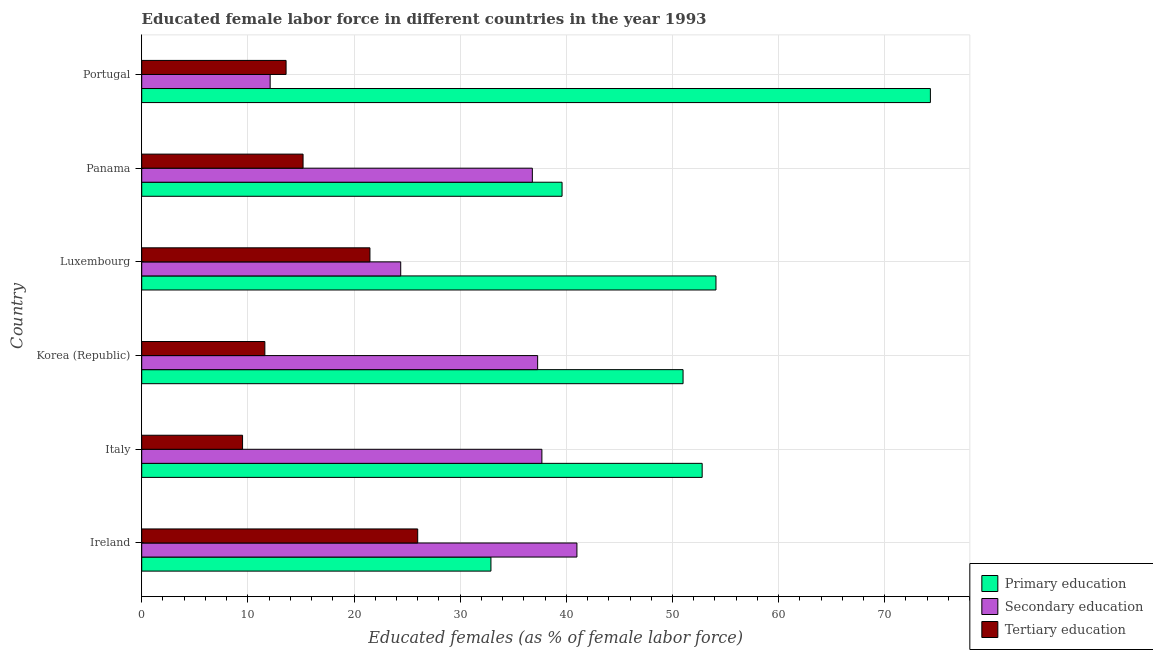How many groups of bars are there?
Your response must be concise. 6. What is the label of the 5th group of bars from the top?
Provide a succinct answer. Italy. What is the percentage of female labor force who received tertiary education in Luxembourg?
Make the answer very short. 21.5. Across all countries, what is the minimum percentage of female labor force who received tertiary education?
Offer a very short reply. 9.5. In which country was the percentage of female labor force who received tertiary education maximum?
Offer a terse response. Ireland. In which country was the percentage of female labor force who received secondary education minimum?
Provide a succinct answer. Portugal. What is the total percentage of female labor force who received tertiary education in the graph?
Provide a short and direct response. 97.4. What is the difference between the percentage of female labor force who received secondary education in Panama and that in Portugal?
Your answer should be very brief. 24.7. What is the difference between the percentage of female labor force who received primary education in Panama and the percentage of female labor force who received tertiary education in Korea (Republic)?
Provide a succinct answer. 28. What is the average percentage of female labor force who received tertiary education per country?
Give a very brief answer. 16.23. What is the difference between the percentage of female labor force who received secondary education and percentage of female labor force who received tertiary education in Italy?
Ensure brevity in your answer.  28.2. What is the ratio of the percentage of female labor force who received primary education in Korea (Republic) to that in Luxembourg?
Give a very brief answer. 0.94. Is the percentage of female labor force who received tertiary education in Korea (Republic) less than that in Panama?
Your answer should be compact. Yes. Is the difference between the percentage of female labor force who received tertiary education in Ireland and Panama greater than the difference between the percentage of female labor force who received primary education in Ireland and Panama?
Provide a short and direct response. Yes. What is the difference between the highest and the second highest percentage of female labor force who received secondary education?
Make the answer very short. 3.3. In how many countries, is the percentage of female labor force who received tertiary education greater than the average percentage of female labor force who received tertiary education taken over all countries?
Ensure brevity in your answer.  2. What does the 1st bar from the top in Italy represents?
Give a very brief answer. Tertiary education. Are all the bars in the graph horizontal?
Your answer should be very brief. Yes. How many countries are there in the graph?
Give a very brief answer. 6. Does the graph contain any zero values?
Provide a short and direct response. No. Where does the legend appear in the graph?
Your answer should be compact. Bottom right. How many legend labels are there?
Ensure brevity in your answer.  3. What is the title of the graph?
Your response must be concise. Educated female labor force in different countries in the year 1993. What is the label or title of the X-axis?
Keep it short and to the point. Educated females (as % of female labor force). What is the Educated females (as % of female labor force) in Primary education in Ireland?
Give a very brief answer. 32.9. What is the Educated females (as % of female labor force) in Secondary education in Ireland?
Offer a terse response. 41. What is the Educated females (as % of female labor force) in Tertiary education in Ireland?
Offer a very short reply. 26. What is the Educated females (as % of female labor force) of Primary education in Italy?
Give a very brief answer. 52.8. What is the Educated females (as % of female labor force) in Secondary education in Italy?
Keep it short and to the point. 37.7. What is the Educated females (as % of female labor force) of Primary education in Korea (Republic)?
Offer a very short reply. 51. What is the Educated females (as % of female labor force) in Secondary education in Korea (Republic)?
Provide a short and direct response. 37.3. What is the Educated females (as % of female labor force) of Tertiary education in Korea (Republic)?
Offer a terse response. 11.6. What is the Educated females (as % of female labor force) in Primary education in Luxembourg?
Offer a very short reply. 54.1. What is the Educated females (as % of female labor force) in Secondary education in Luxembourg?
Make the answer very short. 24.4. What is the Educated females (as % of female labor force) in Primary education in Panama?
Provide a short and direct response. 39.6. What is the Educated females (as % of female labor force) of Secondary education in Panama?
Keep it short and to the point. 36.8. What is the Educated females (as % of female labor force) in Tertiary education in Panama?
Offer a very short reply. 15.2. What is the Educated females (as % of female labor force) of Primary education in Portugal?
Your response must be concise. 74.3. What is the Educated females (as % of female labor force) of Secondary education in Portugal?
Make the answer very short. 12.1. What is the Educated females (as % of female labor force) of Tertiary education in Portugal?
Your response must be concise. 13.6. Across all countries, what is the maximum Educated females (as % of female labor force) of Primary education?
Ensure brevity in your answer.  74.3. Across all countries, what is the maximum Educated females (as % of female labor force) in Tertiary education?
Ensure brevity in your answer.  26. Across all countries, what is the minimum Educated females (as % of female labor force) of Primary education?
Provide a short and direct response. 32.9. Across all countries, what is the minimum Educated females (as % of female labor force) of Secondary education?
Give a very brief answer. 12.1. What is the total Educated females (as % of female labor force) of Primary education in the graph?
Provide a succinct answer. 304.7. What is the total Educated females (as % of female labor force) of Secondary education in the graph?
Give a very brief answer. 189.3. What is the total Educated females (as % of female labor force) in Tertiary education in the graph?
Provide a short and direct response. 97.4. What is the difference between the Educated females (as % of female labor force) of Primary education in Ireland and that in Italy?
Your response must be concise. -19.9. What is the difference between the Educated females (as % of female labor force) of Tertiary education in Ireland and that in Italy?
Your answer should be very brief. 16.5. What is the difference between the Educated females (as % of female labor force) in Primary education in Ireland and that in Korea (Republic)?
Keep it short and to the point. -18.1. What is the difference between the Educated females (as % of female labor force) of Primary education in Ireland and that in Luxembourg?
Provide a succinct answer. -21.2. What is the difference between the Educated females (as % of female labor force) of Tertiary education in Ireland and that in Luxembourg?
Your response must be concise. 4.5. What is the difference between the Educated females (as % of female labor force) in Primary education in Ireland and that in Portugal?
Make the answer very short. -41.4. What is the difference between the Educated females (as % of female labor force) in Secondary education in Ireland and that in Portugal?
Give a very brief answer. 28.9. What is the difference between the Educated females (as % of female labor force) in Primary education in Italy and that in Korea (Republic)?
Your answer should be compact. 1.8. What is the difference between the Educated females (as % of female labor force) of Primary education in Italy and that in Luxembourg?
Your response must be concise. -1.3. What is the difference between the Educated females (as % of female labor force) in Secondary education in Italy and that in Luxembourg?
Your answer should be very brief. 13.3. What is the difference between the Educated females (as % of female labor force) of Tertiary education in Italy and that in Luxembourg?
Offer a terse response. -12. What is the difference between the Educated females (as % of female labor force) in Primary education in Italy and that in Panama?
Provide a succinct answer. 13.2. What is the difference between the Educated females (as % of female labor force) in Secondary education in Italy and that in Panama?
Provide a succinct answer. 0.9. What is the difference between the Educated females (as % of female labor force) in Primary education in Italy and that in Portugal?
Provide a succinct answer. -21.5. What is the difference between the Educated females (as % of female labor force) of Secondary education in Italy and that in Portugal?
Your response must be concise. 25.6. What is the difference between the Educated females (as % of female labor force) of Tertiary education in Italy and that in Portugal?
Your answer should be compact. -4.1. What is the difference between the Educated females (as % of female labor force) of Secondary education in Korea (Republic) and that in Luxembourg?
Your answer should be very brief. 12.9. What is the difference between the Educated females (as % of female labor force) in Primary education in Korea (Republic) and that in Portugal?
Give a very brief answer. -23.3. What is the difference between the Educated females (as % of female labor force) of Secondary education in Korea (Republic) and that in Portugal?
Your answer should be compact. 25.2. What is the difference between the Educated females (as % of female labor force) of Tertiary education in Luxembourg and that in Panama?
Make the answer very short. 6.3. What is the difference between the Educated females (as % of female labor force) in Primary education in Luxembourg and that in Portugal?
Ensure brevity in your answer.  -20.2. What is the difference between the Educated females (as % of female labor force) of Secondary education in Luxembourg and that in Portugal?
Keep it short and to the point. 12.3. What is the difference between the Educated females (as % of female labor force) of Tertiary education in Luxembourg and that in Portugal?
Make the answer very short. 7.9. What is the difference between the Educated females (as % of female labor force) of Primary education in Panama and that in Portugal?
Your answer should be compact. -34.7. What is the difference between the Educated females (as % of female labor force) of Secondary education in Panama and that in Portugal?
Give a very brief answer. 24.7. What is the difference between the Educated females (as % of female labor force) in Primary education in Ireland and the Educated females (as % of female labor force) in Secondary education in Italy?
Make the answer very short. -4.8. What is the difference between the Educated females (as % of female labor force) in Primary education in Ireland and the Educated females (as % of female labor force) in Tertiary education in Italy?
Give a very brief answer. 23.4. What is the difference between the Educated females (as % of female labor force) in Secondary education in Ireland and the Educated females (as % of female labor force) in Tertiary education in Italy?
Your response must be concise. 31.5. What is the difference between the Educated females (as % of female labor force) in Primary education in Ireland and the Educated females (as % of female labor force) in Tertiary education in Korea (Republic)?
Provide a succinct answer. 21.3. What is the difference between the Educated females (as % of female labor force) in Secondary education in Ireland and the Educated females (as % of female labor force) in Tertiary education in Korea (Republic)?
Provide a short and direct response. 29.4. What is the difference between the Educated females (as % of female labor force) of Primary education in Ireland and the Educated females (as % of female labor force) of Tertiary education in Luxembourg?
Make the answer very short. 11.4. What is the difference between the Educated females (as % of female labor force) of Primary education in Ireland and the Educated females (as % of female labor force) of Tertiary education in Panama?
Provide a short and direct response. 17.7. What is the difference between the Educated females (as % of female labor force) of Secondary education in Ireland and the Educated females (as % of female labor force) of Tertiary education in Panama?
Your answer should be compact. 25.8. What is the difference between the Educated females (as % of female labor force) in Primary education in Ireland and the Educated females (as % of female labor force) in Secondary education in Portugal?
Make the answer very short. 20.8. What is the difference between the Educated females (as % of female labor force) in Primary education in Ireland and the Educated females (as % of female labor force) in Tertiary education in Portugal?
Offer a terse response. 19.3. What is the difference between the Educated females (as % of female labor force) in Secondary education in Ireland and the Educated females (as % of female labor force) in Tertiary education in Portugal?
Ensure brevity in your answer.  27.4. What is the difference between the Educated females (as % of female labor force) of Primary education in Italy and the Educated females (as % of female labor force) of Tertiary education in Korea (Republic)?
Provide a succinct answer. 41.2. What is the difference between the Educated females (as % of female labor force) in Secondary education in Italy and the Educated females (as % of female labor force) in Tertiary education in Korea (Republic)?
Keep it short and to the point. 26.1. What is the difference between the Educated females (as % of female labor force) in Primary education in Italy and the Educated females (as % of female labor force) in Secondary education in Luxembourg?
Your response must be concise. 28.4. What is the difference between the Educated females (as % of female labor force) in Primary education in Italy and the Educated females (as % of female labor force) in Tertiary education in Luxembourg?
Your response must be concise. 31.3. What is the difference between the Educated females (as % of female labor force) of Secondary education in Italy and the Educated females (as % of female labor force) of Tertiary education in Luxembourg?
Your answer should be very brief. 16.2. What is the difference between the Educated females (as % of female labor force) of Primary education in Italy and the Educated females (as % of female labor force) of Secondary education in Panama?
Your answer should be compact. 16. What is the difference between the Educated females (as % of female labor force) of Primary education in Italy and the Educated females (as % of female labor force) of Tertiary education in Panama?
Make the answer very short. 37.6. What is the difference between the Educated females (as % of female labor force) in Secondary education in Italy and the Educated females (as % of female labor force) in Tertiary education in Panama?
Give a very brief answer. 22.5. What is the difference between the Educated females (as % of female labor force) of Primary education in Italy and the Educated females (as % of female labor force) of Secondary education in Portugal?
Make the answer very short. 40.7. What is the difference between the Educated females (as % of female labor force) in Primary education in Italy and the Educated females (as % of female labor force) in Tertiary education in Portugal?
Your answer should be compact. 39.2. What is the difference between the Educated females (as % of female labor force) of Secondary education in Italy and the Educated females (as % of female labor force) of Tertiary education in Portugal?
Your response must be concise. 24.1. What is the difference between the Educated females (as % of female labor force) of Primary education in Korea (Republic) and the Educated females (as % of female labor force) of Secondary education in Luxembourg?
Offer a terse response. 26.6. What is the difference between the Educated females (as % of female labor force) in Primary education in Korea (Republic) and the Educated females (as % of female labor force) in Tertiary education in Luxembourg?
Make the answer very short. 29.5. What is the difference between the Educated females (as % of female labor force) in Primary education in Korea (Republic) and the Educated females (as % of female labor force) in Secondary education in Panama?
Provide a short and direct response. 14.2. What is the difference between the Educated females (as % of female labor force) in Primary education in Korea (Republic) and the Educated females (as % of female labor force) in Tertiary education in Panama?
Your answer should be very brief. 35.8. What is the difference between the Educated females (as % of female labor force) of Secondary education in Korea (Republic) and the Educated females (as % of female labor force) of Tertiary education in Panama?
Your answer should be very brief. 22.1. What is the difference between the Educated females (as % of female labor force) of Primary education in Korea (Republic) and the Educated females (as % of female labor force) of Secondary education in Portugal?
Give a very brief answer. 38.9. What is the difference between the Educated females (as % of female labor force) of Primary education in Korea (Republic) and the Educated females (as % of female labor force) of Tertiary education in Portugal?
Your response must be concise. 37.4. What is the difference between the Educated females (as % of female labor force) of Secondary education in Korea (Republic) and the Educated females (as % of female labor force) of Tertiary education in Portugal?
Make the answer very short. 23.7. What is the difference between the Educated females (as % of female labor force) in Primary education in Luxembourg and the Educated females (as % of female labor force) in Secondary education in Panama?
Give a very brief answer. 17.3. What is the difference between the Educated females (as % of female labor force) in Primary education in Luxembourg and the Educated females (as % of female labor force) in Tertiary education in Panama?
Your answer should be compact. 38.9. What is the difference between the Educated females (as % of female labor force) in Primary education in Luxembourg and the Educated females (as % of female labor force) in Tertiary education in Portugal?
Keep it short and to the point. 40.5. What is the difference between the Educated females (as % of female labor force) in Primary education in Panama and the Educated females (as % of female labor force) in Secondary education in Portugal?
Your answer should be compact. 27.5. What is the difference between the Educated females (as % of female labor force) in Primary education in Panama and the Educated females (as % of female labor force) in Tertiary education in Portugal?
Make the answer very short. 26. What is the difference between the Educated females (as % of female labor force) in Secondary education in Panama and the Educated females (as % of female labor force) in Tertiary education in Portugal?
Your answer should be compact. 23.2. What is the average Educated females (as % of female labor force) of Primary education per country?
Keep it short and to the point. 50.78. What is the average Educated females (as % of female labor force) of Secondary education per country?
Your answer should be compact. 31.55. What is the average Educated females (as % of female labor force) of Tertiary education per country?
Provide a short and direct response. 16.23. What is the difference between the Educated females (as % of female labor force) of Primary education and Educated females (as % of female labor force) of Secondary education in Ireland?
Make the answer very short. -8.1. What is the difference between the Educated females (as % of female labor force) of Primary education and Educated females (as % of female labor force) of Tertiary education in Ireland?
Make the answer very short. 6.9. What is the difference between the Educated females (as % of female labor force) of Primary education and Educated females (as % of female labor force) of Secondary education in Italy?
Make the answer very short. 15.1. What is the difference between the Educated females (as % of female labor force) in Primary education and Educated females (as % of female labor force) in Tertiary education in Italy?
Keep it short and to the point. 43.3. What is the difference between the Educated females (as % of female labor force) of Secondary education and Educated females (as % of female labor force) of Tertiary education in Italy?
Offer a terse response. 28.2. What is the difference between the Educated females (as % of female labor force) in Primary education and Educated females (as % of female labor force) in Tertiary education in Korea (Republic)?
Your answer should be compact. 39.4. What is the difference between the Educated females (as % of female labor force) in Secondary education and Educated females (as % of female labor force) in Tertiary education in Korea (Republic)?
Offer a terse response. 25.7. What is the difference between the Educated females (as % of female labor force) of Primary education and Educated females (as % of female labor force) of Secondary education in Luxembourg?
Give a very brief answer. 29.7. What is the difference between the Educated females (as % of female labor force) of Primary education and Educated females (as % of female labor force) of Tertiary education in Luxembourg?
Ensure brevity in your answer.  32.6. What is the difference between the Educated females (as % of female labor force) of Primary education and Educated females (as % of female labor force) of Secondary education in Panama?
Offer a very short reply. 2.8. What is the difference between the Educated females (as % of female labor force) in Primary education and Educated females (as % of female labor force) in Tertiary education in Panama?
Offer a terse response. 24.4. What is the difference between the Educated females (as % of female labor force) in Secondary education and Educated females (as % of female labor force) in Tertiary education in Panama?
Your answer should be very brief. 21.6. What is the difference between the Educated females (as % of female labor force) of Primary education and Educated females (as % of female labor force) of Secondary education in Portugal?
Offer a terse response. 62.2. What is the difference between the Educated females (as % of female labor force) of Primary education and Educated females (as % of female labor force) of Tertiary education in Portugal?
Offer a terse response. 60.7. What is the ratio of the Educated females (as % of female labor force) in Primary education in Ireland to that in Italy?
Provide a succinct answer. 0.62. What is the ratio of the Educated females (as % of female labor force) in Secondary education in Ireland to that in Italy?
Keep it short and to the point. 1.09. What is the ratio of the Educated females (as % of female labor force) of Tertiary education in Ireland to that in Italy?
Make the answer very short. 2.74. What is the ratio of the Educated females (as % of female labor force) of Primary education in Ireland to that in Korea (Republic)?
Your answer should be very brief. 0.65. What is the ratio of the Educated females (as % of female labor force) in Secondary education in Ireland to that in Korea (Republic)?
Offer a terse response. 1.1. What is the ratio of the Educated females (as % of female labor force) of Tertiary education in Ireland to that in Korea (Republic)?
Offer a very short reply. 2.24. What is the ratio of the Educated females (as % of female labor force) of Primary education in Ireland to that in Luxembourg?
Your answer should be very brief. 0.61. What is the ratio of the Educated females (as % of female labor force) of Secondary education in Ireland to that in Luxembourg?
Offer a very short reply. 1.68. What is the ratio of the Educated females (as % of female labor force) of Tertiary education in Ireland to that in Luxembourg?
Make the answer very short. 1.21. What is the ratio of the Educated females (as % of female labor force) in Primary education in Ireland to that in Panama?
Your answer should be very brief. 0.83. What is the ratio of the Educated females (as % of female labor force) in Secondary education in Ireland to that in Panama?
Provide a succinct answer. 1.11. What is the ratio of the Educated females (as % of female labor force) of Tertiary education in Ireland to that in Panama?
Your answer should be very brief. 1.71. What is the ratio of the Educated females (as % of female labor force) in Primary education in Ireland to that in Portugal?
Your answer should be very brief. 0.44. What is the ratio of the Educated females (as % of female labor force) in Secondary education in Ireland to that in Portugal?
Keep it short and to the point. 3.39. What is the ratio of the Educated females (as % of female labor force) of Tertiary education in Ireland to that in Portugal?
Ensure brevity in your answer.  1.91. What is the ratio of the Educated females (as % of female labor force) in Primary education in Italy to that in Korea (Republic)?
Your answer should be very brief. 1.04. What is the ratio of the Educated females (as % of female labor force) of Secondary education in Italy to that in Korea (Republic)?
Your response must be concise. 1.01. What is the ratio of the Educated females (as % of female labor force) in Tertiary education in Italy to that in Korea (Republic)?
Offer a very short reply. 0.82. What is the ratio of the Educated females (as % of female labor force) in Secondary education in Italy to that in Luxembourg?
Give a very brief answer. 1.55. What is the ratio of the Educated females (as % of female labor force) in Tertiary education in Italy to that in Luxembourg?
Your response must be concise. 0.44. What is the ratio of the Educated females (as % of female labor force) in Primary education in Italy to that in Panama?
Your answer should be very brief. 1.33. What is the ratio of the Educated females (as % of female labor force) in Secondary education in Italy to that in Panama?
Offer a terse response. 1.02. What is the ratio of the Educated females (as % of female labor force) in Primary education in Italy to that in Portugal?
Make the answer very short. 0.71. What is the ratio of the Educated females (as % of female labor force) in Secondary education in Italy to that in Portugal?
Offer a terse response. 3.12. What is the ratio of the Educated females (as % of female labor force) in Tertiary education in Italy to that in Portugal?
Offer a very short reply. 0.7. What is the ratio of the Educated females (as % of female labor force) of Primary education in Korea (Republic) to that in Luxembourg?
Offer a terse response. 0.94. What is the ratio of the Educated females (as % of female labor force) of Secondary education in Korea (Republic) to that in Luxembourg?
Offer a terse response. 1.53. What is the ratio of the Educated females (as % of female labor force) in Tertiary education in Korea (Republic) to that in Luxembourg?
Make the answer very short. 0.54. What is the ratio of the Educated females (as % of female labor force) of Primary education in Korea (Republic) to that in Panama?
Offer a very short reply. 1.29. What is the ratio of the Educated females (as % of female labor force) in Secondary education in Korea (Republic) to that in Panama?
Offer a terse response. 1.01. What is the ratio of the Educated females (as % of female labor force) in Tertiary education in Korea (Republic) to that in Panama?
Provide a short and direct response. 0.76. What is the ratio of the Educated females (as % of female labor force) in Primary education in Korea (Republic) to that in Portugal?
Provide a succinct answer. 0.69. What is the ratio of the Educated females (as % of female labor force) of Secondary education in Korea (Republic) to that in Portugal?
Give a very brief answer. 3.08. What is the ratio of the Educated females (as % of female labor force) of Tertiary education in Korea (Republic) to that in Portugal?
Provide a short and direct response. 0.85. What is the ratio of the Educated females (as % of female labor force) of Primary education in Luxembourg to that in Panama?
Provide a short and direct response. 1.37. What is the ratio of the Educated females (as % of female labor force) of Secondary education in Luxembourg to that in Panama?
Provide a short and direct response. 0.66. What is the ratio of the Educated females (as % of female labor force) in Tertiary education in Luxembourg to that in Panama?
Provide a succinct answer. 1.41. What is the ratio of the Educated females (as % of female labor force) in Primary education in Luxembourg to that in Portugal?
Your answer should be very brief. 0.73. What is the ratio of the Educated females (as % of female labor force) in Secondary education in Luxembourg to that in Portugal?
Your answer should be very brief. 2.02. What is the ratio of the Educated females (as % of female labor force) of Tertiary education in Luxembourg to that in Portugal?
Keep it short and to the point. 1.58. What is the ratio of the Educated females (as % of female labor force) in Primary education in Panama to that in Portugal?
Ensure brevity in your answer.  0.53. What is the ratio of the Educated females (as % of female labor force) in Secondary education in Panama to that in Portugal?
Make the answer very short. 3.04. What is the ratio of the Educated females (as % of female labor force) of Tertiary education in Panama to that in Portugal?
Your answer should be compact. 1.12. What is the difference between the highest and the second highest Educated females (as % of female labor force) in Primary education?
Offer a terse response. 20.2. What is the difference between the highest and the second highest Educated females (as % of female labor force) of Tertiary education?
Provide a succinct answer. 4.5. What is the difference between the highest and the lowest Educated females (as % of female labor force) of Primary education?
Your response must be concise. 41.4. What is the difference between the highest and the lowest Educated females (as % of female labor force) of Secondary education?
Offer a terse response. 28.9. What is the difference between the highest and the lowest Educated females (as % of female labor force) of Tertiary education?
Offer a terse response. 16.5. 